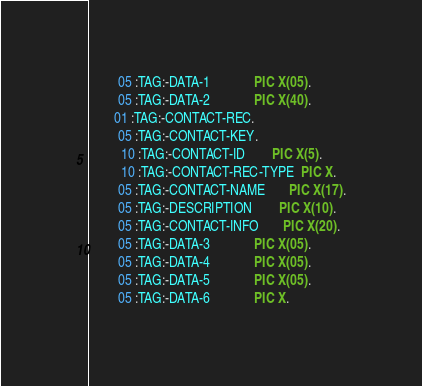<code> <loc_0><loc_0><loc_500><loc_500><_COBOL_>        05 :TAG:-DATA-1             PIC X(05).
        05 :TAG:-DATA-2             PIC X(40).
       01 :TAG:-CONTACT-REC.
        05 :TAG:-CONTACT-KEY.
         10 :TAG:-CONTACT-ID        PIC X(5).
         10 :TAG:-CONTACT-REC-TYPE  PIC X.
        05 :TAG:-CONTACT-NAME       PIC X(17).
        05 :TAG:-DESCRIPTION        PIC X(10).
        05 :TAG:-CONTACT-INFO       PIC X(20).
        05 :TAG:-DATA-3             PIC X(05).
        05 :TAG:-DATA-4             PIC X(05).
        05 :TAG:-DATA-5             PIC X(05).
        05 :TAG:-DATA-6             PIC X.</code> 